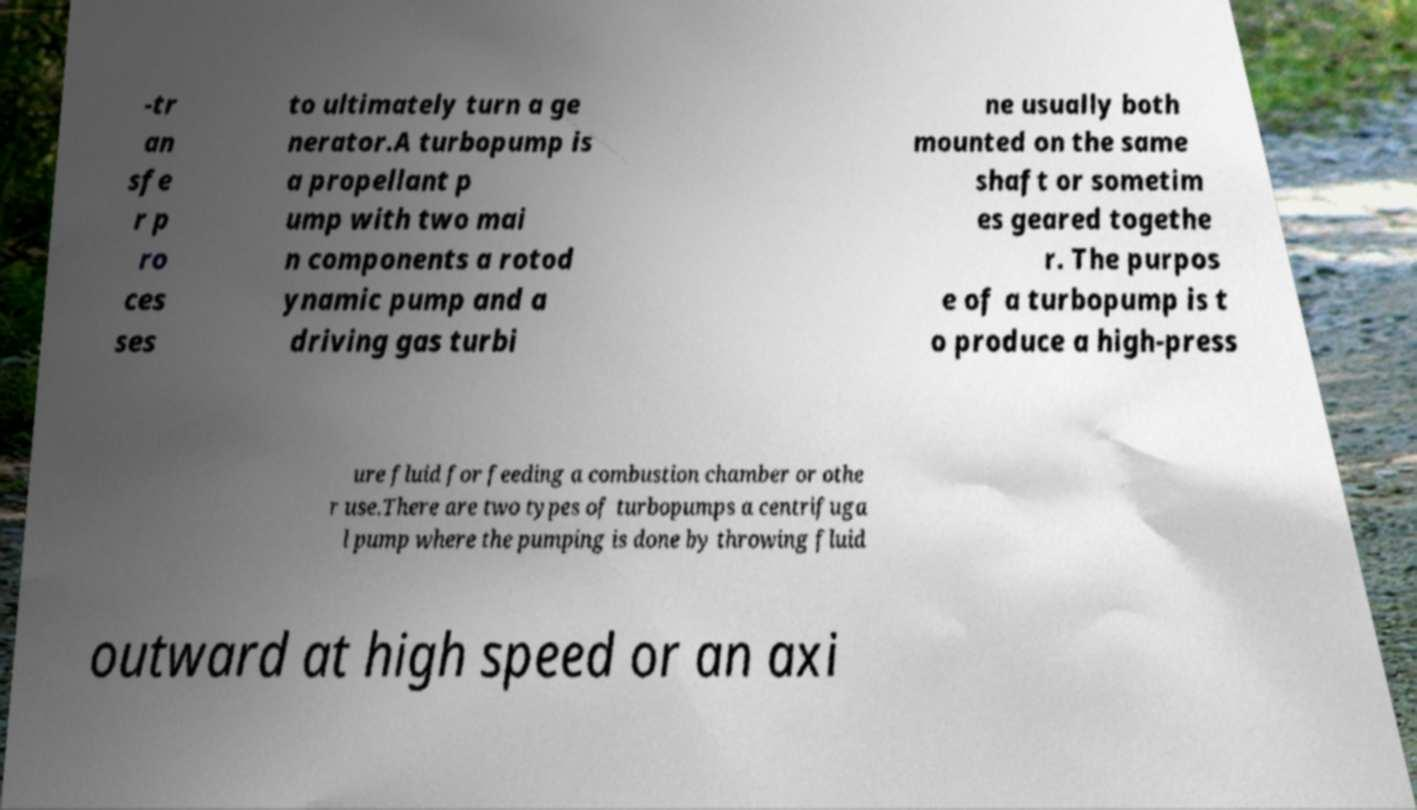For documentation purposes, I need the text within this image transcribed. Could you provide that? -tr an sfe r p ro ces ses to ultimately turn a ge nerator.A turbopump is a propellant p ump with two mai n components a rotod ynamic pump and a driving gas turbi ne usually both mounted on the same shaft or sometim es geared togethe r. The purpos e of a turbopump is t o produce a high-press ure fluid for feeding a combustion chamber or othe r use.There are two types of turbopumps a centrifuga l pump where the pumping is done by throwing fluid outward at high speed or an axi 